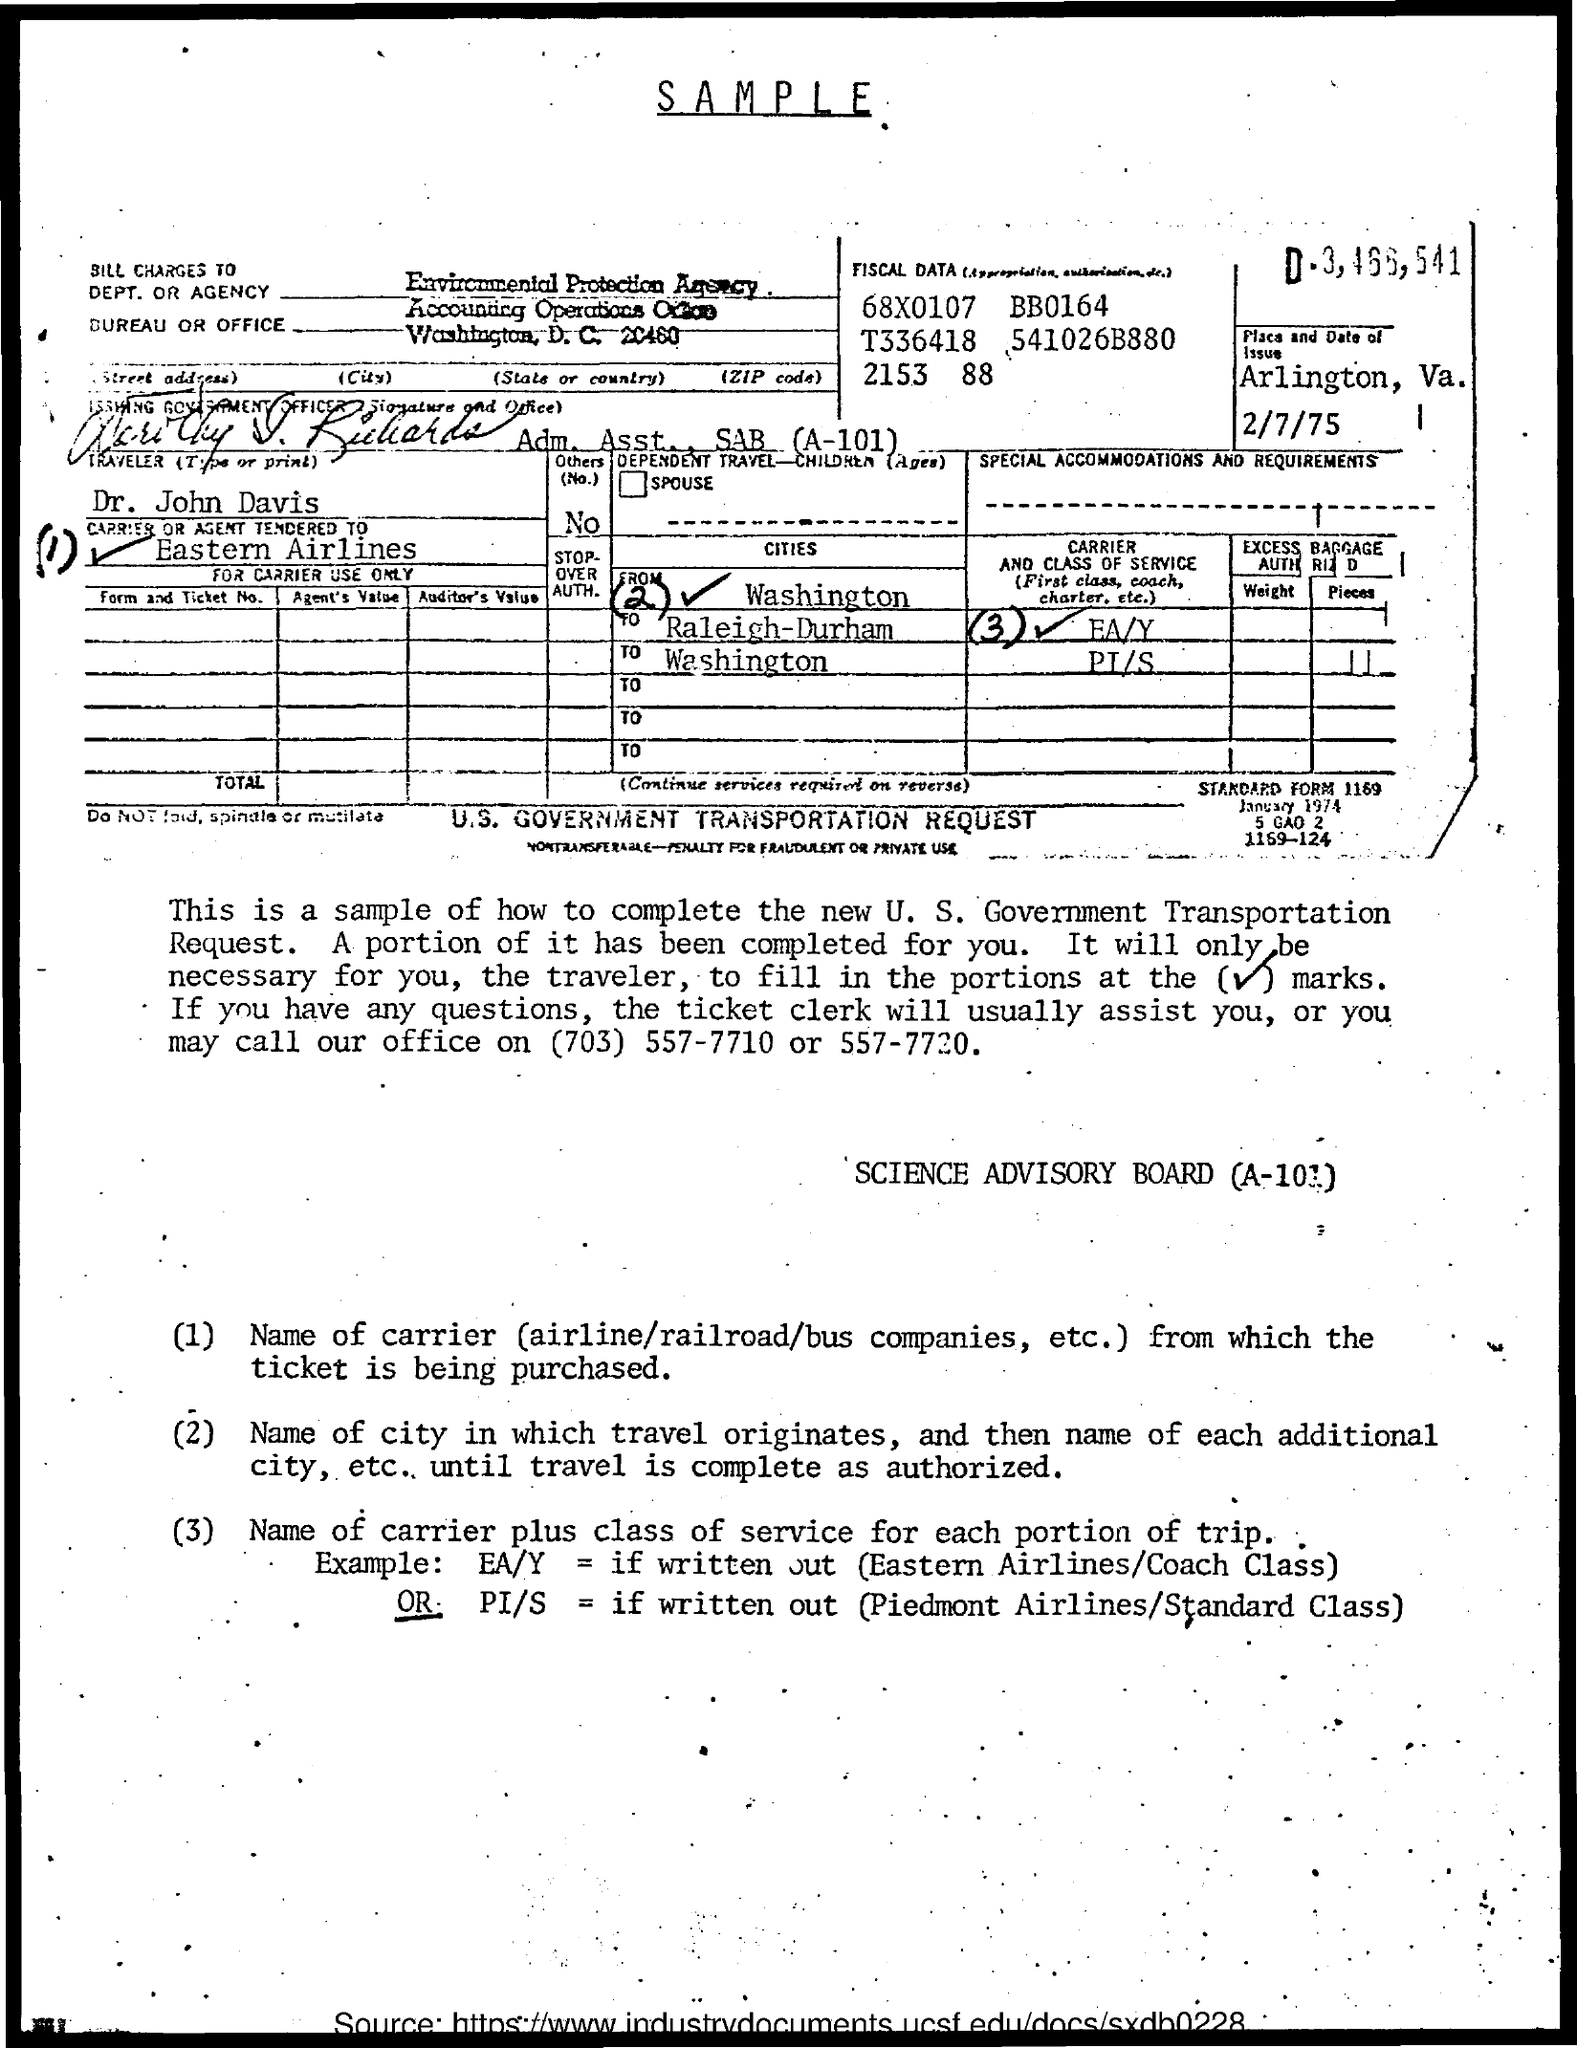To whom is the bill charged to?
Provide a succinct answer. Environmental Protection Agency. 